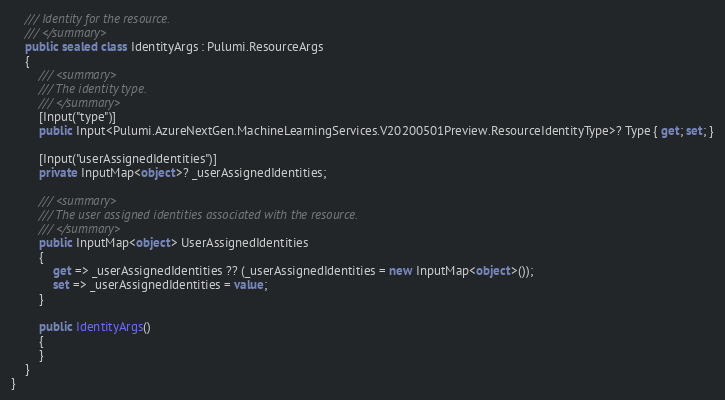Convert code to text. <code><loc_0><loc_0><loc_500><loc_500><_C#_>    /// Identity for the resource.
    /// </summary>
    public sealed class IdentityArgs : Pulumi.ResourceArgs
    {
        /// <summary>
        /// The identity type.
        /// </summary>
        [Input("type")]
        public Input<Pulumi.AzureNextGen.MachineLearningServices.V20200501Preview.ResourceIdentityType>? Type { get; set; }

        [Input("userAssignedIdentities")]
        private InputMap<object>? _userAssignedIdentities;

        /// <summary>
        /// The user assigned identities associated with the resource.
        /// </summary>
        public InputMap<object> UserAssignedIdentities
        {
            get => _userAssignedIdentities ?? (_userAssignedIdentities = new InputMap<object>());
            set => _userAssignedIdentities = value;
        }

        public IdentityArgs()
        {
        }
    }
}
</code> 